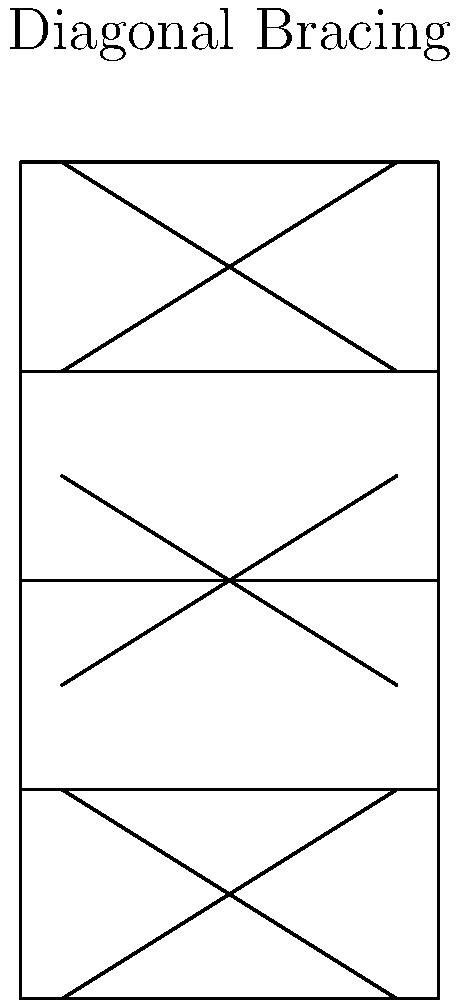As an artist living in San Francisco, you're interested in incorporating architectural elements into your work. You've noticed many buildings feature diagonal bracing for earthquake resistance. What is the primary purpose of diagonal bracing in earthquake-resistant building design, as shown in the sketch? To understand the purpose of diagonal bracing in earthquake-resistant building design, let's break it down step-by-step:

1. Earthquake forces: During an earthquake, buildings experience lateral (side-to-side) forces that can cause them to sway.

2. Structural weakness: Without proper reinforcement, buildings are most vulnerable to these lateral forces at the joints between vertical columns and horizontal beams.

3. Triangulation: Diagonal bracing creates triangular shapes within the building's frame. Triangles are inherently stable shapes in structural engineering.

4. Load distribution: The diagonal braces help distribute the lateral loads throughout the structure more evenly.

5. Increased rigidity: By connecting opposite corners of a rectangular frame, diagonal braces increase the overall rigidity of the structure.

6. Resistance to deformation: The braces resist tension and compression forces, preventing the building frame from deforming into a parallelogram shape during seismic activity.

7. Energy dissipation: Properly designed bracing systems can also help dissipate seismic energy, reducing the overall impact on the building.

8. Lightweight solution: Compared to other seismic reinforcement methods, diagonal bracing is relatively lightweight, making it an efficient choice for retrofitting existing structures.

The primary purpose of diagonal bracing is to provide lateral stability and resist horizontal forces, ultimately preventing structural failure during an earthquake.
Answer: To provide lateral stability and resist horizontal seismic forces. 